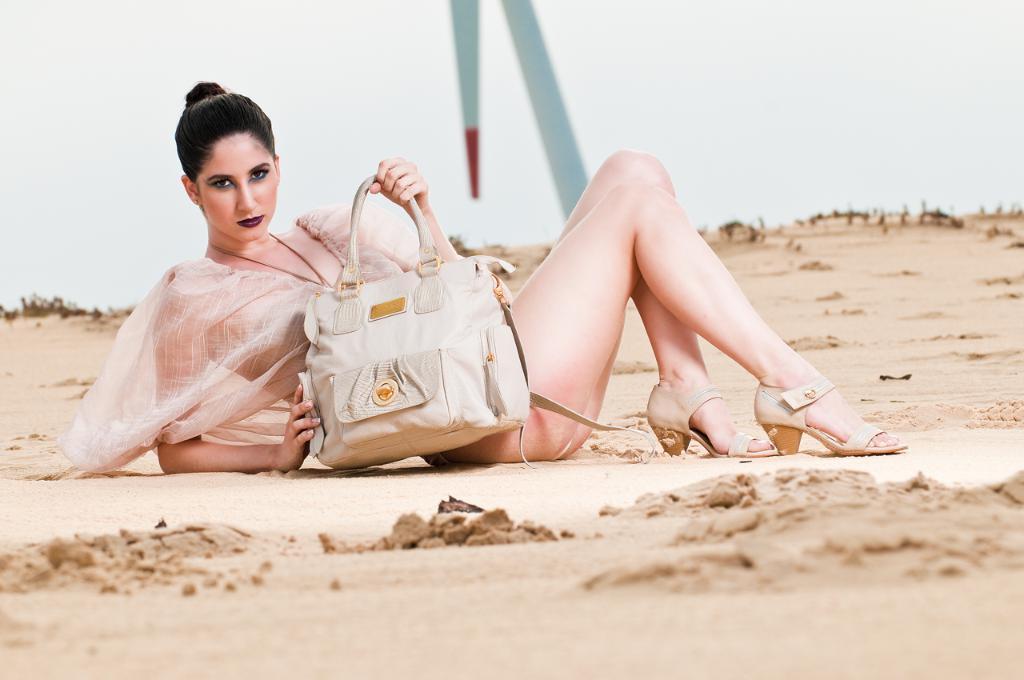In one or two sentences, can you explain what this image depicts? This picture is of outside. In the foreground we can see the ground and there is a woman sitting on the ground holding a bag. In the background we can see the sky. 